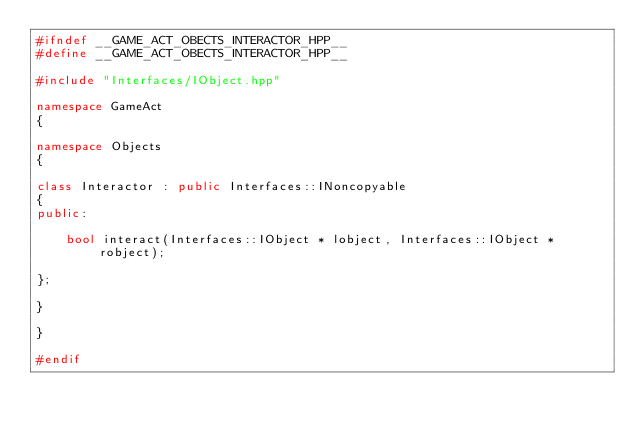Convert code to text. <code><loc_0><loc_0><loc_500><loc_500><_C++_>#ifndef __GAME_ACT_OBECTS_INTERACTOR_HPP__
#define __GAME_ACT_OBECTS_INTERACTOR_HPP__

#include "Interfaces/IObject.hpp"

namespace GameAct
{

namespace Objects
{

class Interactor : public Interfaces::INoncopyable
{
public:

	bool interact(Interfaces::IObject * lobject, Interfaces::IObject * robject);

};

}

}

#endif</code> 